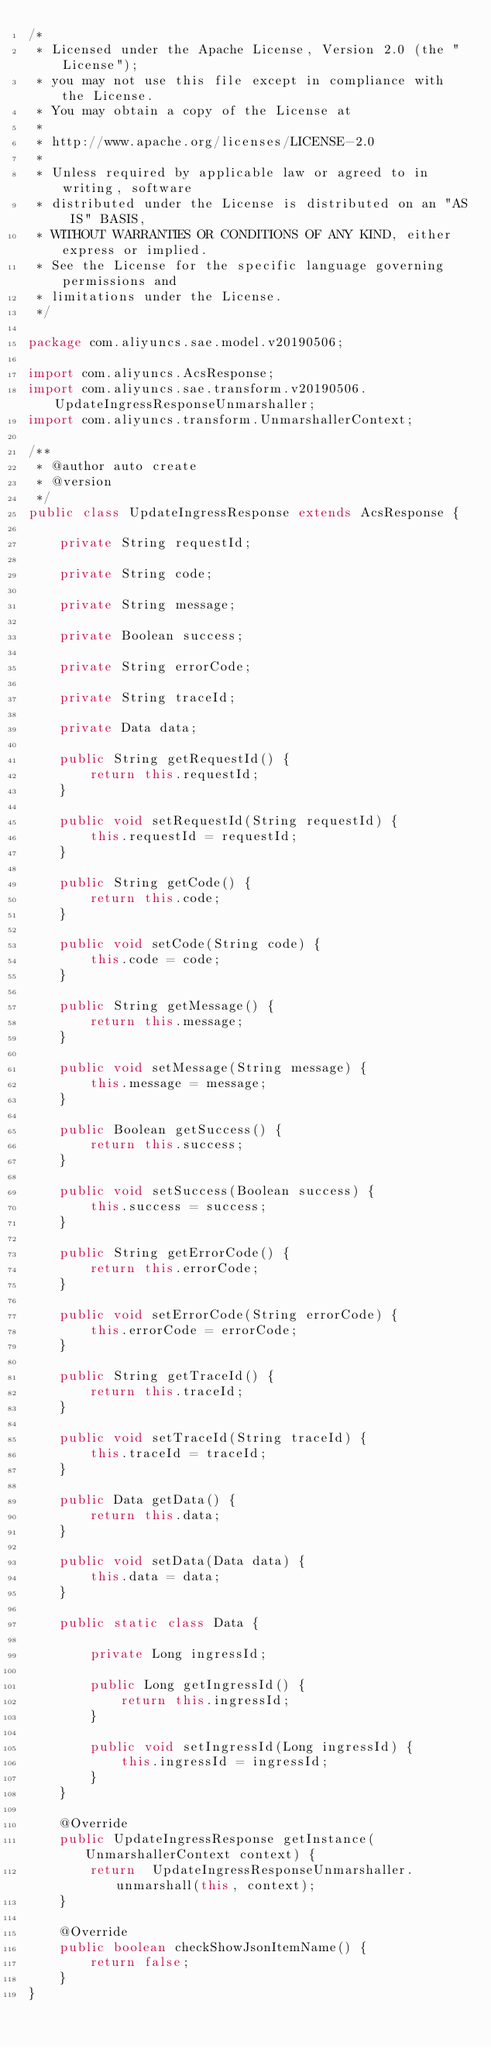<code> <loc_0><loc_0><loc_500><loc_500><_Java_>/*
 * Licensed under the Apache License, Version 2.0 (the "License");
 * you may not use this file except in compliance with the License.
 * You may obtain a copy of the License at
 *
 * http://www.apache.org/licenses/LICENSE-2.0
 *
 * Unless required by applicable law or agreed to in writing, software
 * distributed under the License is distributed on an "AS IS" BASIS,
 * WITHOUT WARRANTIES OR CONDITIONS OF ANY KIND, either express or implied.
 * See the License for the specific language governing permissions and
 * limitations under the License.
 */

package com.aliyuncs.sae.model.v20190506;

import com.aliyuncs.AcsResponse;
import com.aliyuncs.sae.transform.v20190506.UpdateIngressResponseUnmarshaller;
import com.aliyuncs.transform.UnmarshallerContext;

/**
 * @author auto create
 * @version 
 */
public class UpdateIngressResponse extends AcsResponse {

	private String requestId;

	private String code;

	private String message;

	private Boolean success;

	private String errorCode;

	private String traceId;

	private Data data;

	public String getRequestId() {
		return this.requestId;
	}

	public void setRequestId(String requestId) {
		this.requestId = requestId;
	}

	public String getCode() {
		return this.code;
	}

	public void setCode(String code) {
		this.code = code;
	}

	public String getMessage() {
		return this.message;
	}

	public void setMessage(String message) {
		this.message = message;
	}

	public Boolean getSuccess() {
		return this.success;
	}

	public void setSuccess(Boolean success) {
		this.success = success;
	}

	public String getErrorCode() {
		return this.errorCode;
	}

	public void setErrorCode(String errorCode) {
		this.errorCode = errorCode;
	}

	public String getTraceId() {
		return this.traceId;
	}

	public void setTraceId(String traceId) {
		this.traceId = traceId;
	}

	public Data getData() {
		return this.data;
	}

	public void setData(Data data) {
		this.data = data;
	}

	public static class Data {

		private Long ingressId;

		public Long getIngressId() {
			return this.ingressId;
		}

		public void setIngressId(Long ingressId) {
			this.ingressId = ingressId;
		}
	}

	@Override
	public UpdateIngressResponse getInstance(UnmarshallerContext context) {
		return	UpdateIngressResponseUnmarshaller.unmarshall(this, context);
	}

	@Override
	public boolean checkShowJsonItemName() {
		return false;
	}
}
</code> 